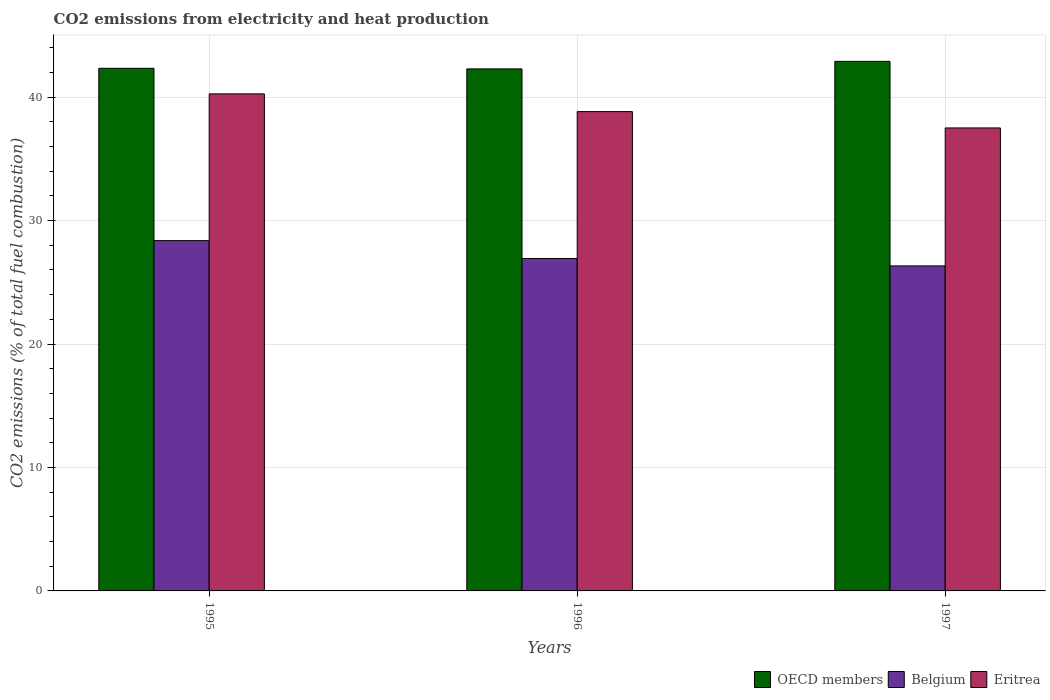How many different coloured bars are there?
Make the answer very short. 3. How many groups of bars are there?
Your response must be concise. 3. Are the number of bars per tick equal to the number of legend labels?
Offer a very short reply. Yes. How many bars are there on the 1st tick from the left?
Make the answer very short. 3. What is the label of the 2nd group of bars from the left?
Offer a very short reply. 1996. What is the amount of CO2 emitted in OECD members in 1995?
Your response must be concise. 42.33. Across all years, what is the maximum amount of CO2 emitted in Eritrea?
Your answer should be very brief. 40.26. Across all years, what is the minimum amount of CO2 emitted in Eritrea?
Keep it short and to the point. 37.5. What is the total amount of CO2 emitted in Eritrea in the graph?
Your answer should be compact. 116.58. What is the difference between the amount of CO2 emitted in Belgium in 1995 and that in 1996?
Your answer should be compact. 1.45. What is the difference between the amount of CO2 emitted in Belgium in 1997 and the amount of CO2 emitted in Eritrea in 1995?
Your answer should be very brief. -13.93. What is the average amount of CO2 emitted in Eritrea per year?
Offer a terse response. 38.86. In the year 1997, what is the difference between the amount of CO2 emitted in OECD members and amount of CO2 emitted in Eritrea?
Your answer should be compact. 5.39. What is the ratio of the amount of CO2 emitted in Eritrea in 1996 to that in 1997?
Your response must be concise. 1.04. Is the amount of CO2 emitted in Belgium in 1995 less than that in 1997?
Your answer should be very brief. No. Is the difference between the amount of CO2 emitted in OECD members in 1995 and 1996 greater than the difference between the amount of CO2 emitted in Eritrea in 1995 and 1996?
Your answer should be very brief. No. What is the difference between the highest and the second highest amount of CO2 emitted in OECD members?
Offer a very short reply. 0.56. What is the difference between the highest and the lowest amount of CO2 emitted in OECD members?
Your response must be concise. 0.61. Is the sum of the amount of CO2 emitted in Belgium in 1995 and 1997 greater than the maximum amount of CO2 emitted in OECD members across all years?
Offer a very short reply. Yes. What does the 3rd bar from the left in 1995 represents?
Give a very brief answer. Eritrea. Are all the bars in the graph horizontal?
Your answer should be compact. No. Are the values on the major ticks of Y-axis written in scientific E-notation?
Offer a very short reply. No. Where does the legend appear in the graph?
Offer a terse response. Bottom right. How many legend labels are there?
Ensure brevity in your answer.  3. How are the legend labels stacked?
Offer a terse response. Horizontal. What is the title of the graph?
Provide a succinct answer. CO2 emissions from electricity and heat production. Does "Rwanda" appear as one of the legend labels in the graph?
Provide a succinct answer. No. What is the label or title of the Y-axis?
Keep it short and to the point. CO2 emissions (% of total fuel combustion). What is the CO2 emissions (% of total fuel combustion) of OECD members in 1995?
Ensure brevity in your answer.  42.33. What is the CO2 emissions (% of total fuel combustion) in Belgium in 1995?
Make the answer very short. 28.37. What is the CO2 emissions (% of total fuel combustion) of Eritrea in 1995?
Offer a terse response. 40.26. What is the CO2 emissions (% of total fuel combustion) in OECD members in 1996?
Your answer should be compact. 42.28. What is the CO2 emissions (% of total fuel combustion) in Belgium in 1996?
Ensure brevity in your answer.  26.93. What is the CO2 emissions (% of total fuel combustion) of Eritrea in 1996?
Your response must be concise. 38.82. What is the CO2 emissions (% of total fuel combustion) in OECD members in 1997?
Make the answer very short. 42.89. What is the CO2 emissions (% of total fuel combustion) of Belgium in 1997?
Provide a succinct answer. 26.33. What is the CO2 emissions (% of total fuel combustion) of Eritrea in 1997?
Provide a short and direct response. 37.5. Across all years, what is the maximum CO2 emissions (% of total fuel combustion) in OECD members?
Your answer should be compact. 42.89. Across all years, what is the maximum CO2 emissions (% of total fuel combustion) in Belgium?
Provide a short and direct response. 28.37. Across all years, what is the maximum CO2 emissions (% of total fuel combustion) of Eritrea?
Keep it short and to the point. 40.26. Across all years, what is the minimum CO2 emissions (% of total fuel combustion) in OECD members?
Keep it short and to the point. 42.28. Across all years, what is the minimum CO2 emissions (% of total fuel combustion) of Belgium?
Your answer should be very brief. 26.33. Across all years, what is the minimum CO2 emissions (% of total fuel combustion) of Eritrea?
Your answer should be compact. 37.5. What is the total CO2 emissions (% of total fuel combustion) of OECD members in the graph?
Your response must be concise. 127.51. What is the total CO2 emissions (% of total fuel combustion) of Belgium in the graph?
Your answer should be very brief. 81.62. What is the total CO2 emissions (% of total fuel combustion) of Eritrea in the graph?
Offer a very short reply. 116.58. What is the difference between the CO2 emissions (% of total fuel combustion) of OECD members in 1995 and that in 1996?
Your answer should be compact. 0.05. What is the difference between the CO2 emissions (% of total fuel combustion) of Belgium in 1995 and that in 1996?
Ensure brevity in your answer.  1.45. What is the difference between the CO2 emissions (% of total fuel combustion) in Eritrea in 1995 and that in 1996?
Provide a succinct answer. 1.44. What is the difference between the CO2 emissions (% of total fuel combustion) of OECD members in 1995 and that in 1997?
Keep it short and to the point. -0.56. What is the difference between the CO2 emissions (% of total fuel combustion) of Belgium in 1995 and that in 1997?
Offer a very short reply. 2.05. What is the difference between the CO2 emissions (% of total fuel combustion) in Eritrea in 1995 and that in 1997?
Give a very brief answer. 2.76. What is the difference between the CO2 emissions (% of total fuel combustion) in OECD members in 1996 and that in 1997?
Your response must be concise. -0.61. What is the difference between the CO2 emissions (% of total fuel combustion) in Belgium in 1996 and that in 1997?
Offer a terse response. 0.6. What is the difference between the CO2 emissions (% of total fuel combustion) in Eritrea in 1996 and that in 1997?
Provide a short and direct response. 1.32. What is the difference between the CO2 emissions (% of total fuel combustion) of OECD members in 1995 and the CO2 emissions (% of total fuel combustion) of Belgium in 1996?
Make the answer very short. 15.41. What is the difference between the CO2 emissions (% of total fuel combustion) of OECD members in 1995 and the CO2 emissions (% of total fuel combustion) of Eritrea in 1996?
Ensure brevity in your answer.  3.51. What is the difference between the CO2 emissions (% of total fuel combustion) in Belgium in 1995 and the CO2 emissions (% of total fuel combustion) in Eritrea in 1996?
Provide a short and direct response. -10.45. What is the difference between the CO2 emissions (% of total fuel combustion) in OECD members in 1995 and the CO2 emissions (% of total fuel combustion) in Belgium in 1997?
Ensure brevity in your answer.  16.01. What is the difference between the CO2 emissions (% of total fuel combustion) in OECD members in 1995 and the CO2 emissions (% of total fuel combustion) in Eritrea in 1997?
Keep it short and to the point. 4.83. What is the difference between the CO2 emissions (% of total fuel combustion) of Belgium in 1995 and the CO2 emissions (% of total fuel combustion) of Eritrea in 1997?
Give a very brief answer. -9.13. What is the difference between the CO2 emissions (% of total fuel combustion) of OECD members in 1996 and the CO2 emissions (% of total fuel combustion) of Belgium in 1997?
Ensure brevity in your answer.  15.96. What is the difference between the CO2 emissions (% of total fuel combustion) of OECD members in 1996 and the CO2 emissions (% of total fuel combustion) of Eritrea in 1997?
Your answer should be compact. 4.78. What is the difference between the CO2 emissions (% of total fuel combustion) of Belgium in 1996 and the CO2 emissions (% of total fuel combustion) of Eritrea in 1997?
Provide a succinct answer. -10.57. What is the average CO2 emissions (% of total fuel combustion) in OECD members per year?
Keep it short and to the point. 42.5. What is the average CO2 emissions (% of total fuel combustion) in Belgium per year?
Offer a terse response. 27.21. What is the average CO2 emissions (% of total fuel combustion) in Eritrea per year?
Offer a very short reply. 38.86. In the year 1995, what is the difference between the CO2 emissions (% of total fuel combustion) of OECD members and CO2 emissions (% of total fuel combustion) of Belgium?
Provide a short and direct response. 13.96. In the year 1995, what is the difference between the CO2 emissions (% of total fuel combustion) of OECD members and CO2 emissions (% of total fuel combustion) of Eritrea?
Keep it short and to the point. 2.07. In the year 1995, what is the difference between the CO2 emissions (% of total fuel combustion) in Belgium and CO2 emissions (% of total fuel combustion) in Eritrea?
Ensure brevity in your answer.  -11.89. In the year 1996, what is the difference between the CO2 emissions (% of total fuel combustion) of OECD members and CO2 emissions (% of total fuel combustion) of Belgium?
Give a very brief answer. 15.36. In the year 1996, what is the difference between the CO2 emissions (% of total fuel combustion) of OECD members and CO2 emissions (% of total fuel combustion) of Eritrea?
Provide a short and direct response. 3.46. In the year 1996, what is the difference between the CO2 emissions (% of total fuel combustion) of Belgium and CO2 emissions (% of total fuel combustion) of Eritrea?
Your answer should be very brief. -11.9. In the year 1997, what is the difference between the CO2 emissions (% of total fuel combustion) of OECD members and CO2 emissions (% of total fuel combustion) of Belgium?
Offer a terse response. 16.57. In the year 1997, what is the difference between the CO2 emissions (% of total fuel combustion) of OECD members and CO2 emissions (% of total fuel combustion) of Eritrea?
Provide a succinct answer. 5.39. In the year 1997, what is the difference between the CO2 emissions (% of total fuel combustion) in Belgium and CO2 emissions (% of total fuel combustion) in Eritrea?
Offer a terse response. -11.17. What is the ratio of the CO2 emissions (% of total fuel combustion) of Belgium in 1995 to that in 1996?
Give a very brief answer. 1.05. What is the ratio of the CO2 emissions (% of total fuel combustion) of Eritrea in 1995 to that in 1996?
Ensure brevity in your answer.  1.04. What is the ratio of the CO2 emissions (% of total fuel combustion) in OECD members in 1995 to that in 1997?
Your response must be concise. 0.99. What is the ratio of the CO2 emissions (% of total fuel combustion) of Belgium in 1995 to that in 1997?
Your response must be concise. 1.08. What is the ratio of the CO2 emissions (% of total fuel combustion) of Eritrea in 1995 to that in 1997?
Offer a terse response. 1.07. What is the ratio of the CO2 emissions (% of total fuel combustion) of OECD members in 1996 to that in 1997?
Provide a short and direct response. 0.99. What is the ratio of the CO2 emissions (% of total fuel combustion) in Belgium in 1996 to that in 1997?
Offer a terse response. 1.02. What is the ratio of the CO2 emissions (% of total fuel combustion) of Eritrea in 1996 to that in 1997?
Make the answer very short. 1.04. What is the difference between the highest and the second highest CO2 emissions (% of total fuel combustion) of OECD members?
Your answer should be compact. 0.56. What is the difference between the highest and the second highest CO2 emissions (% of total fuel combustion) in Belgium?
Your answer should be very brief. 1.45. What is the difference between the highest and the second highest CO2 emissions (% of total fuel combustion) of Eritrea?
Offer a very short reply. 1.44. What is the difference between the highest and the lowest CO2 emissions (% of total fuel combustion) of OECD members?
Provide a succinct answer. 0.61. What is the difference between the highest and the lowest CO2 emissions (% of total fuel combustion) in Belgium?
Your answer should be compact. 2.05. What is the difference between the highest and the lowest CO2 emissions (% of total fuel combustion) in Eritrea?
Offer a very short reply. 2.76. 